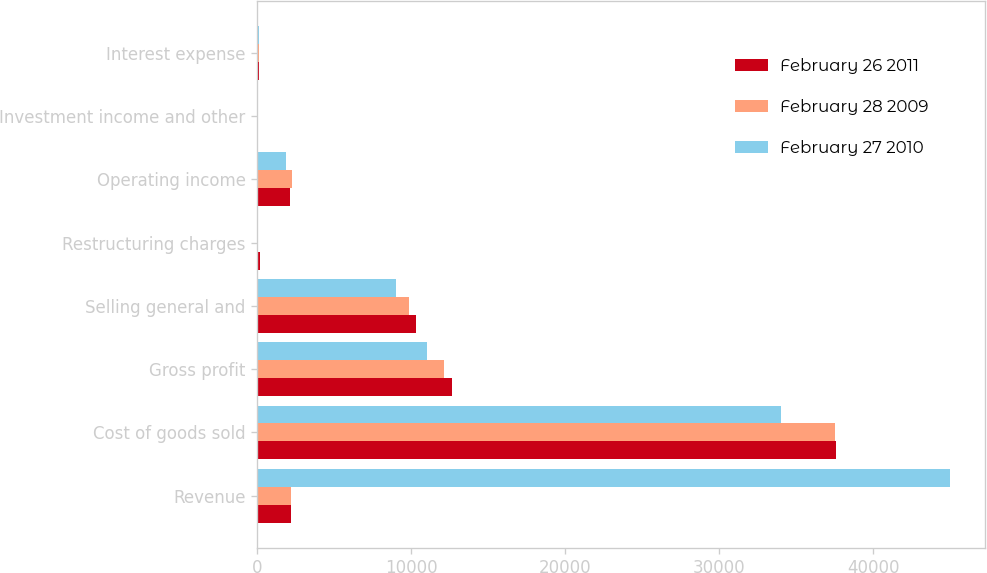Convert chart. <chart><loc_0><loc_0><loc_500><loc_500><stacked_bar_chart><ecel><fcel>Revenue<fcel>Cost of goods sold<fcel>Gross profit<fcel>Selling general and<fcel>Restructuring charges<fcel>Operating income<fcel>Investment income and other<fcel>Interest expense<nl><fcel>February 26 2011<fcel>2174.5<fcel>37611<fcel>12637<fcel>10325<fcel>198<fcel>2114<fcel>51<fcel>87<nl><fcel>February 28 2009<fcel>2174.5<fcel>37534<fcel>12160<fcel>9873<fcel>52<fcel>2235<fcel>54<fcel>94<nl><fcel>February 27 2010<fcel>45015<fcel>34017<fcel>10998<fcel>8984<fcel>78<fcel>1870<fcel>35<fcel>94<nl></chart> 